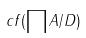<formula> <loc_0><loc_0><loc_500><loc_500>c f ( \prod A / D )</formula> 